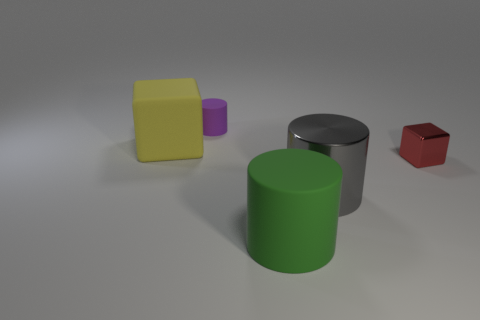The thing that is both in front of the yellow rubber block and behind the gray shiny cylinder is made of what material?
Your response must be concise. Metal. Is the large gray cylinder made of the same material as the small block?
Offer a very short reply. Yes. How many things are both in front of the rubber block and behind the big green cylinder?
Provide a succinct answer. 2. What number of other things are there of the same color as the large metal object?
Provide a succinct answer. 0. What number of purple objects are shiny objects or metallic cubes?
Offer a very short reply. 0. What is the size of the purple object?
Offer a terse response. Small. What number of rubber objects are gray cylinders or big things?
Make the answer very short. 2. Are there fewer big gray cylinders than matte things?
Give a very brief answer. Yes. What number of other objects are the same material as the yellow object?
Give a very brief answer. 2. There is another thing that is the same shape as the yellow rubber thing; what size is it?
Offer a very short reply. Small. 